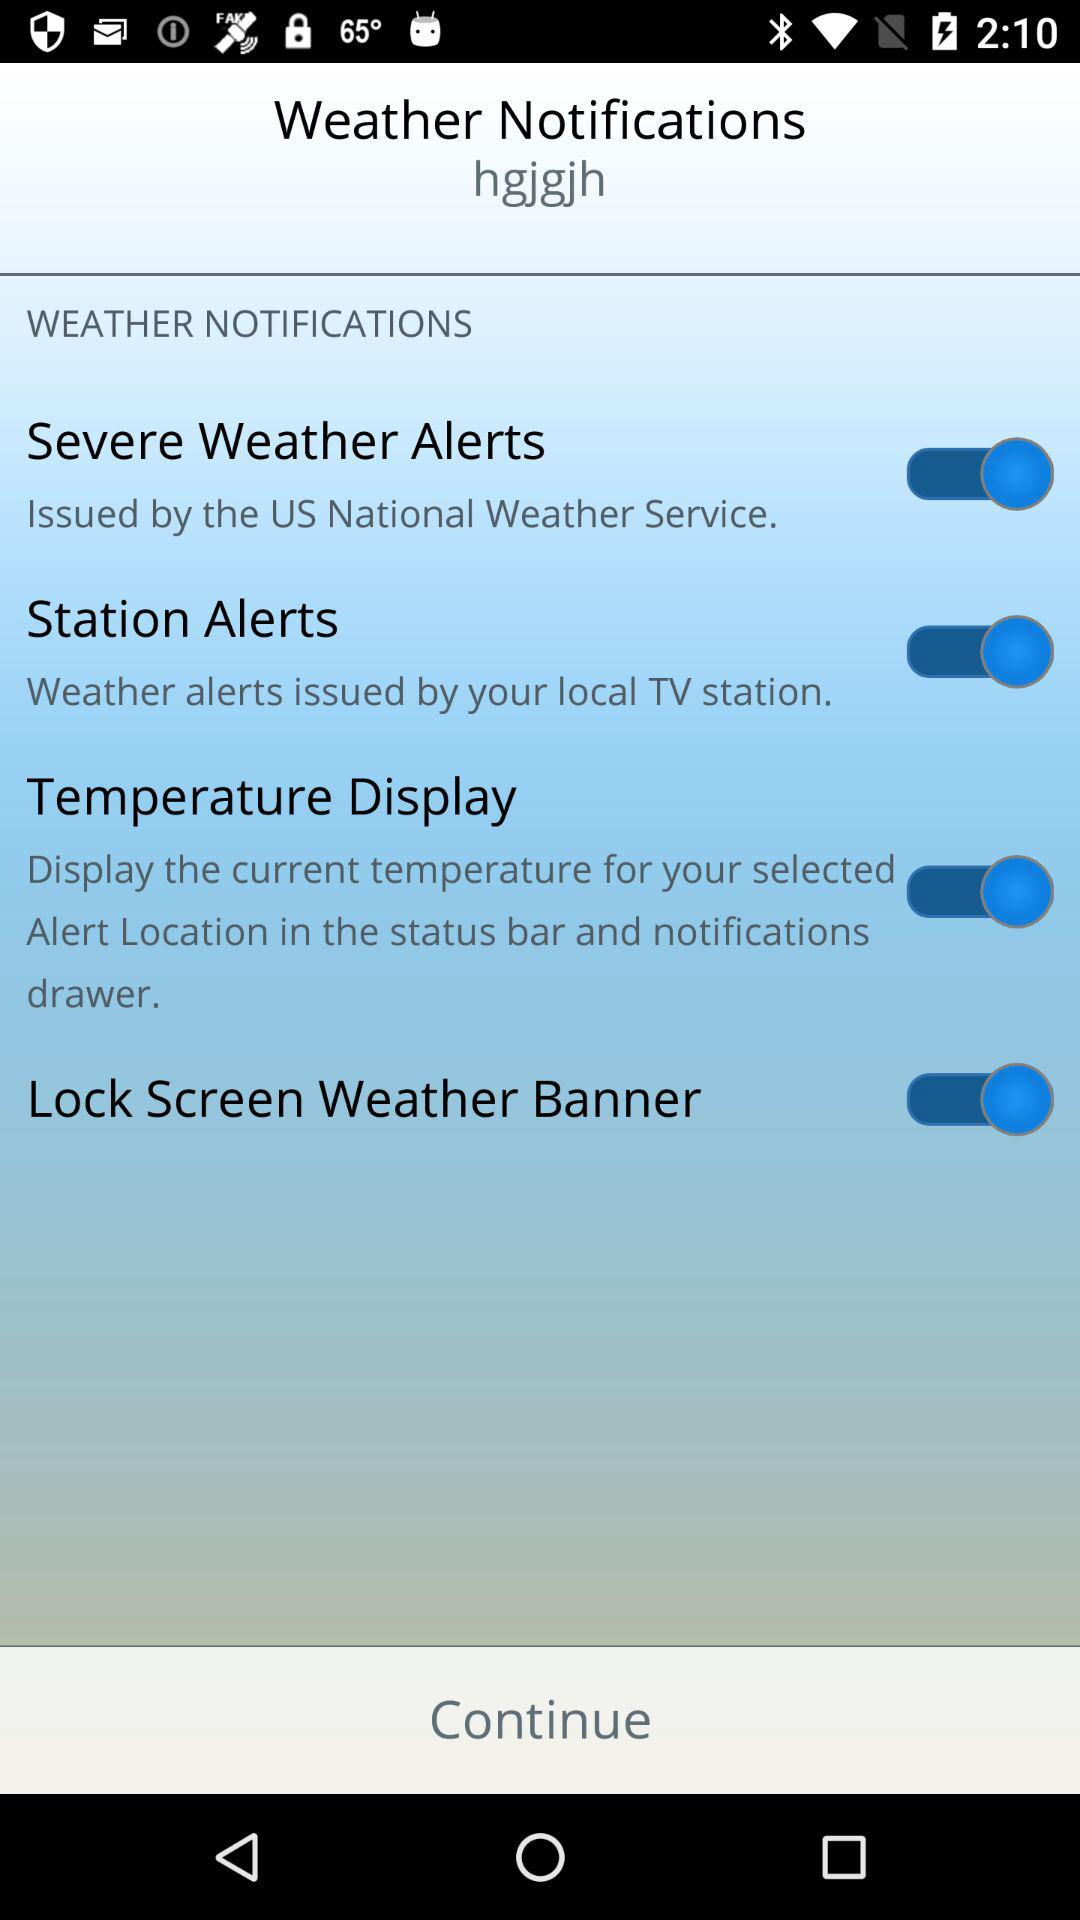What is the status of "Station Alerts"? The status is "on". 